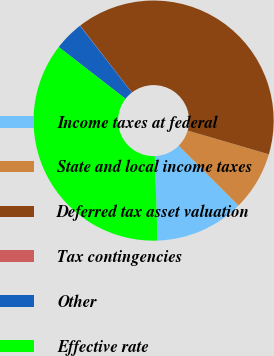Convert chart. <chart><loc_0><loc_0><loc_500><loc_500><pie_chart><fcel>Income taxes at federal<fcel>State and local income taxes<fcel>Deferred tax asset valuation<fcel>Tax contingencies<fcel>Other<fcel>Effective rate<nl><fcel>11.96%<fcel>7.98%<fcel>40.0%<fcel>0.03%<fcel>4.0%<fcel>36.02%<nl></chart> 